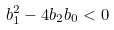Convert formula to latex. <formula><loc_0><loc_0><loc_500><loc_500>b _ { 1 } ^ { 2 } - 4 b _ { 2 } b _ { 0 } < 0</formula> 